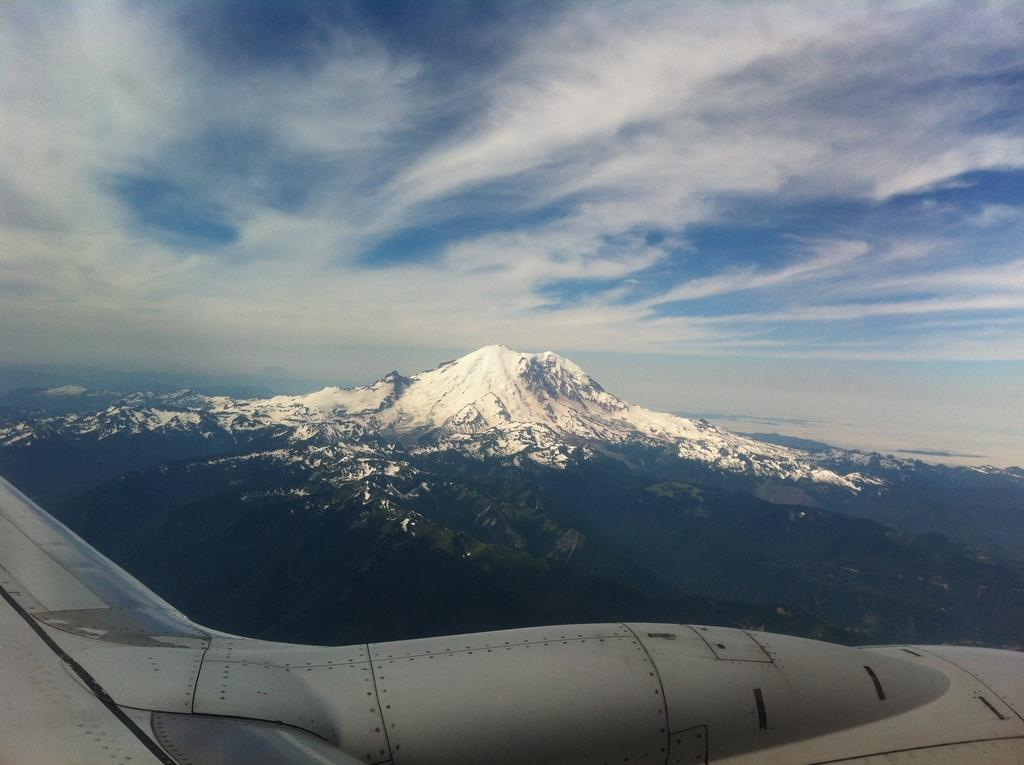What is the main subject of the image? The main subject of the image is the upper part of an aeroplane. What can be seen in the background of the image? There is a mountain behind the aeroplane. How is the mountain characterized? The mountain is covered with snow. What is the condition of the sky in the image? The sky is clear and visible in the image. What type of scissors can be seen cutting through the clouds in the image? There are no scissors present in the image, and no clouds are being cut through. 